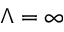Convert formula to latex. <formula><loc_0><loc_0><loc_500><loc_500>\Lambda = \infty</formula> 